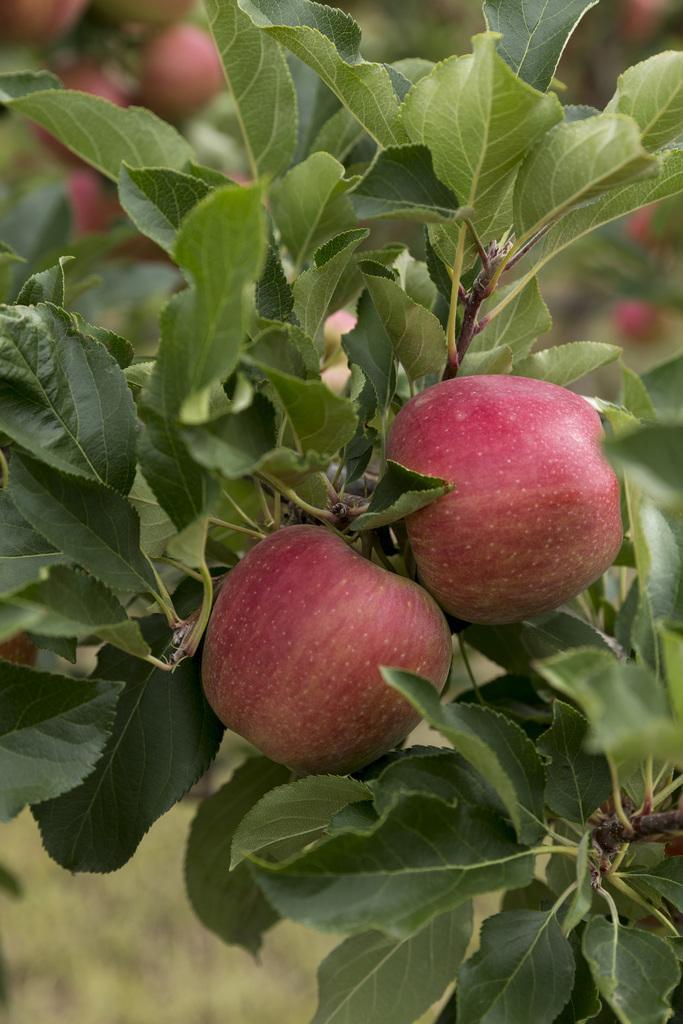Describe this image in one or two sentences. In this image I can see few apples and few green color leaves. Background is blurred. 